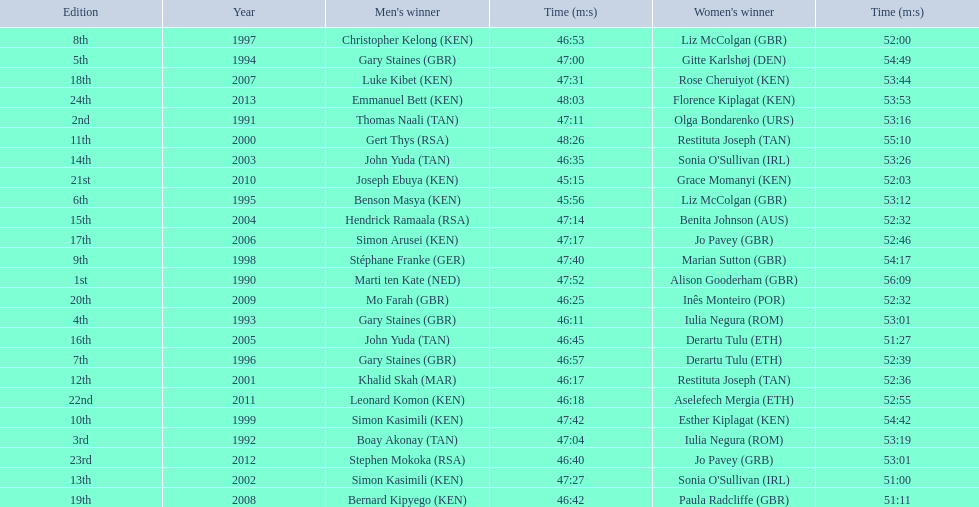Who were all the runners' times between 1990 and 2013? 47:52, 56:09, 47:11, 53:16, 47:04, 53:19, 46:11, 53:01, 47:00, 54:49, 45:56, 53:12, 46:57, 52:39, 46:53, 52:00, 47:40, 54:17, 47:42, 54:42, 48:26, 55:10, 46:17, 52:36, 47:27, 51:00, 46:35, 53:26, 47:14, 52:32, 46:45, 51:27, 47:17, 52:46, 47:31, 53:44, 46:42, 51:11, 46:25, 52:32, 45:15, 52:03, 46:18, 52:55, 46:40, 53:01, 48:03, 53:53. Which was the fastest time? 45:15. Who ran that time? Joseph Ebuya (KEN). 